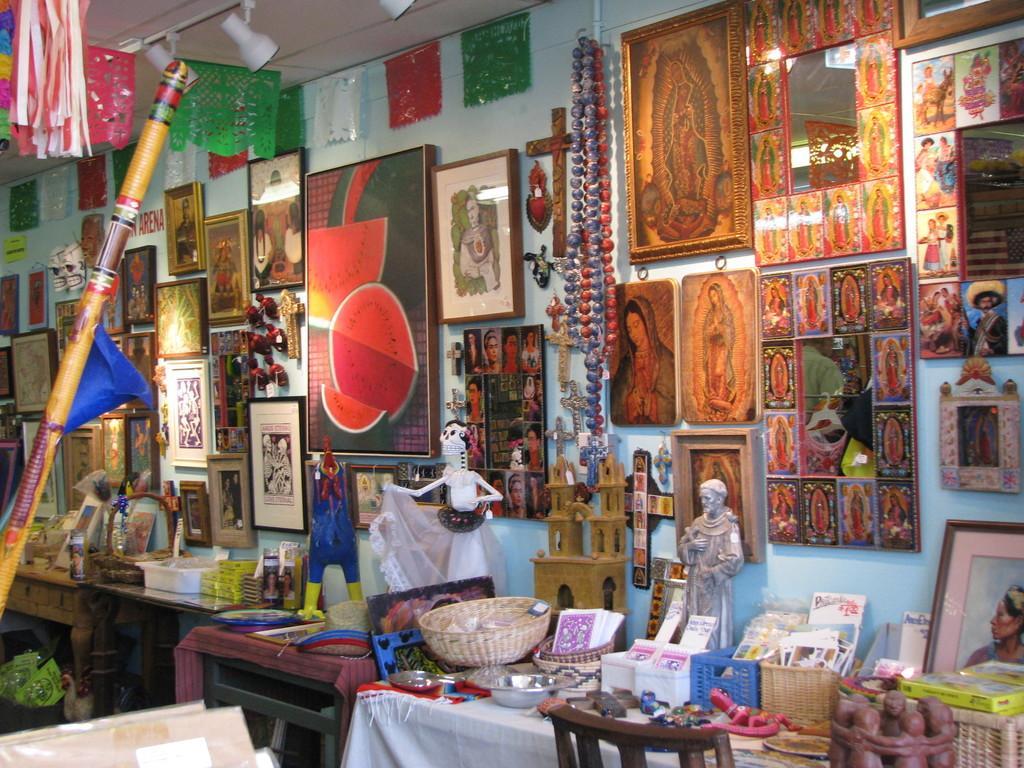Can you describe this image briefly? In the image we can see table on table there is a statue,cards,bowls etc. In the background we can see wall,photo frames and few other objects. 